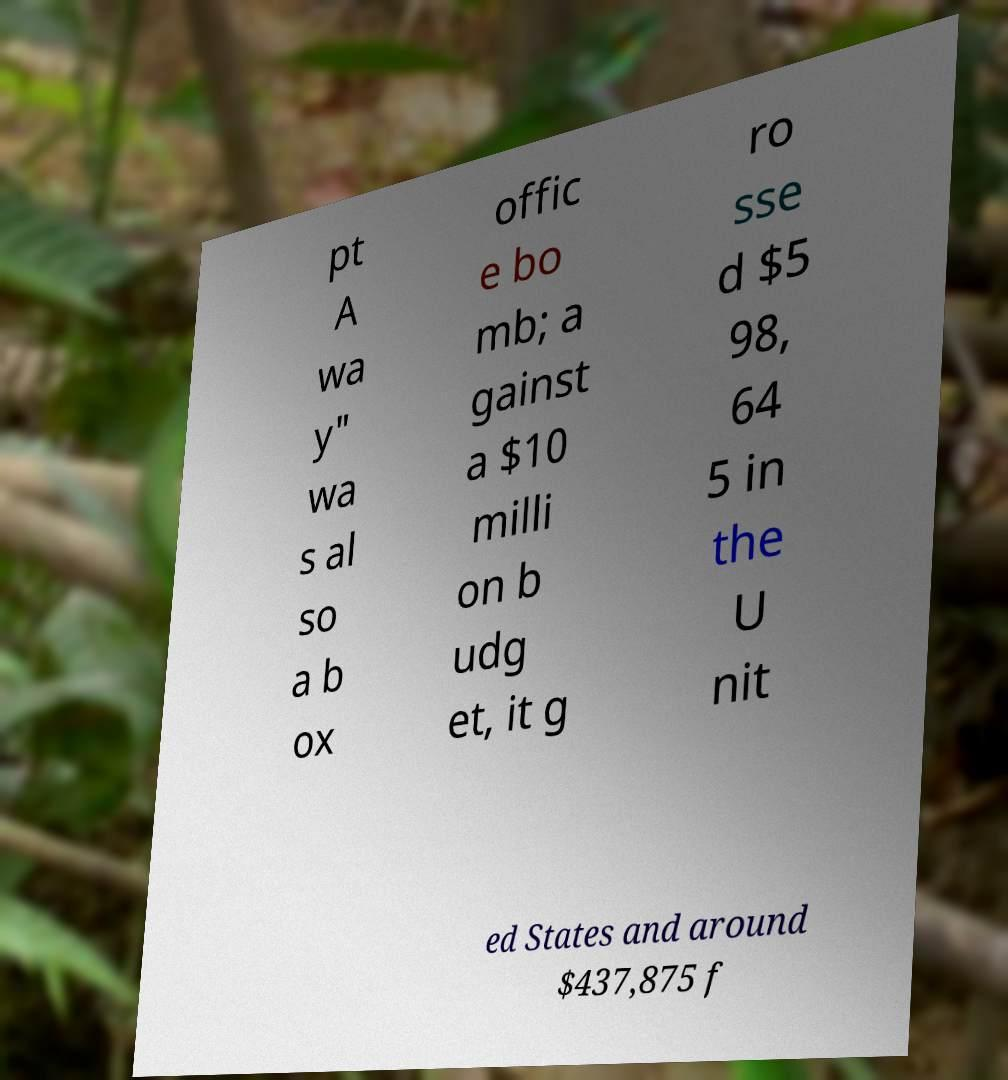For documentation purposes, I need the text within this image transcribed. Could you provide that? pt A wa y" wa s al so a b ox offic e bo mb; a gainst a $10 milli on b udg et, it g ro sse d $5 98, 64 5 in the U nit ed States and around $437,875 f 